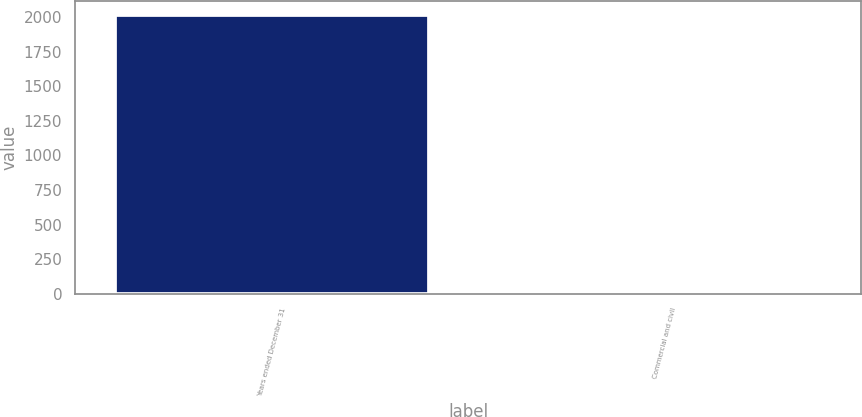Convert chart to OTSL. <chart><loc_0><loc_0><loc_500><loc_500><bar_chart><fcel>Years ended December 31<fcel>Commercial and civil<nl><fcel>2014<fcel>5<nl></chart> 